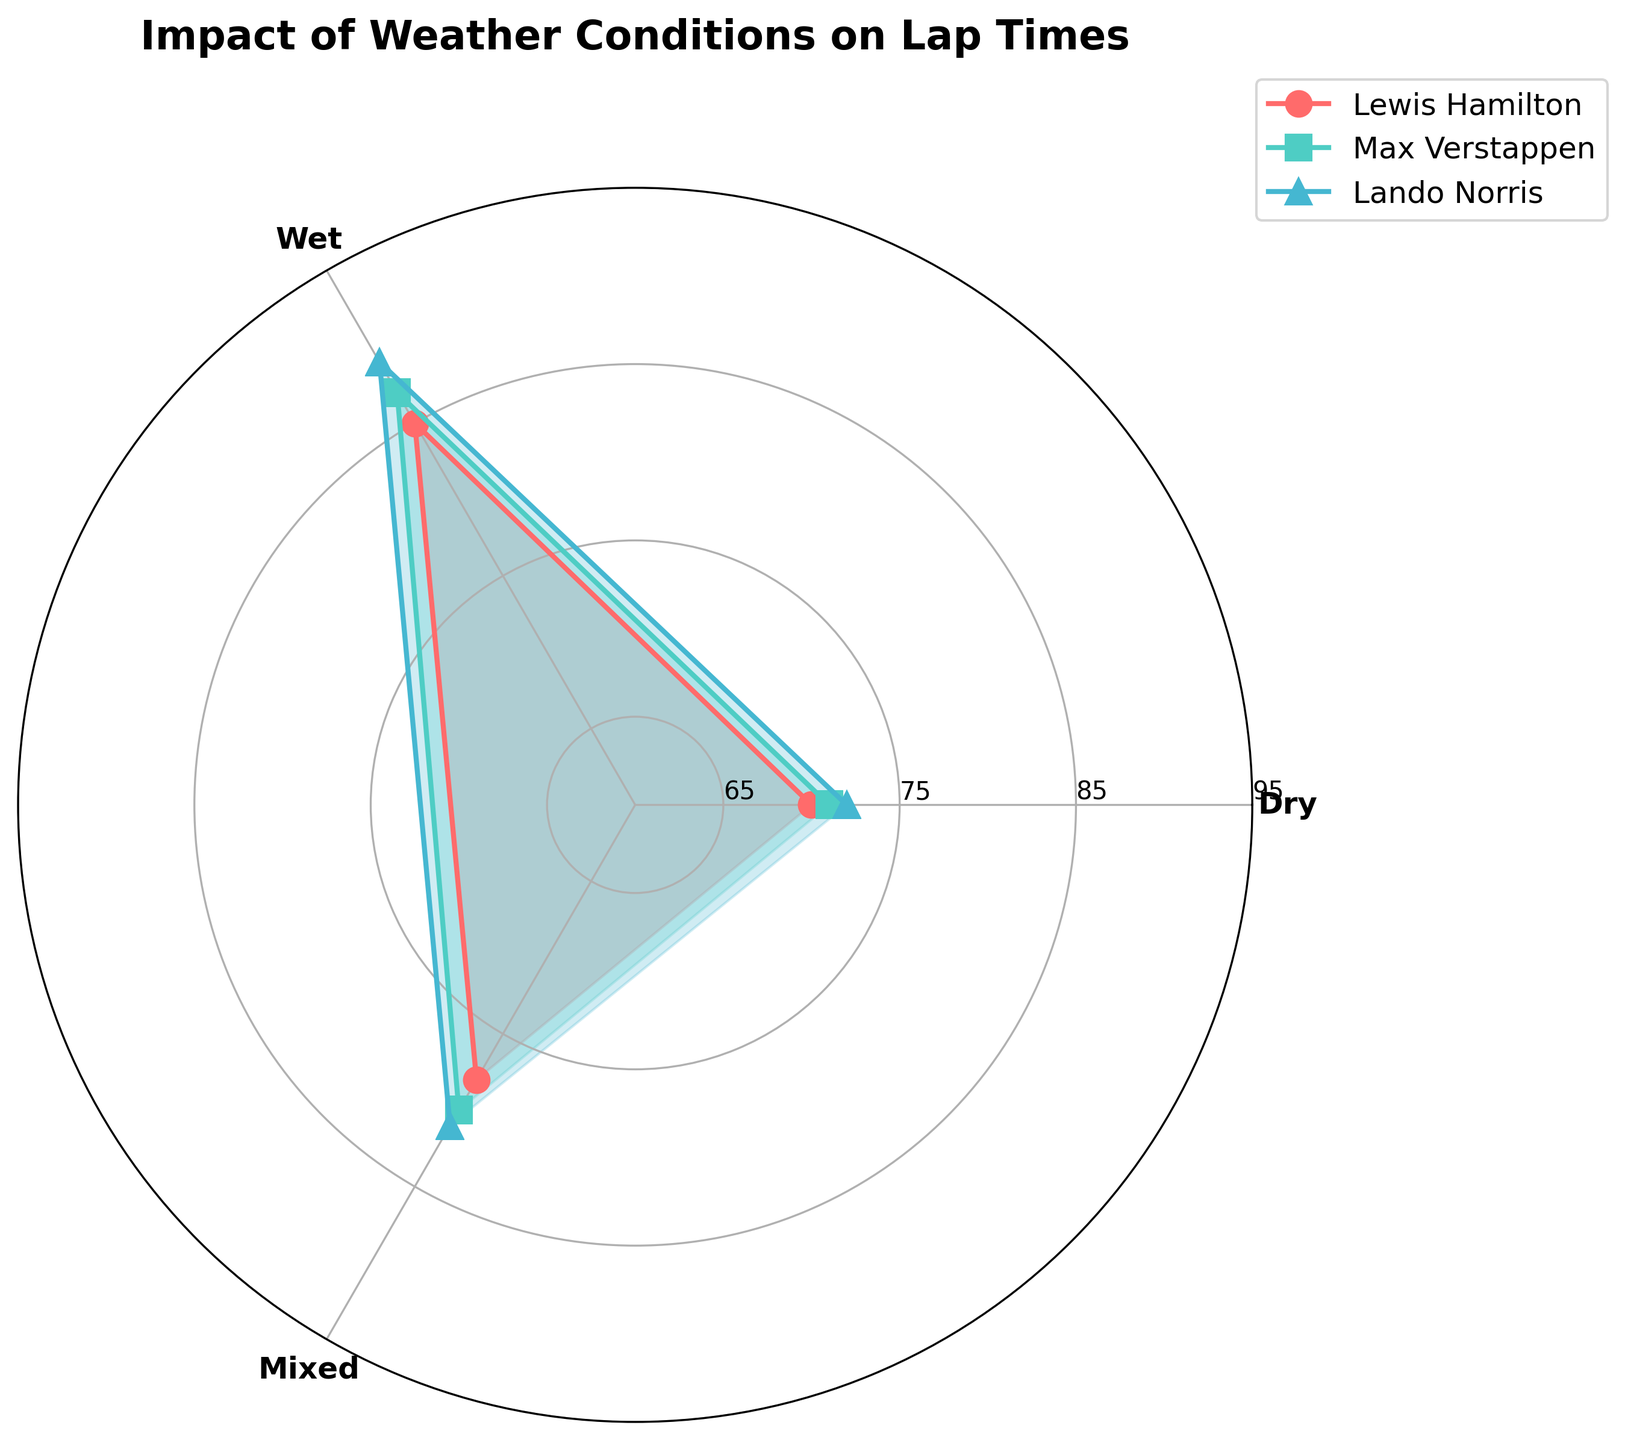What are the weather conditions shown in the figure? The figure has segments representing different weather conditions. We can see labels for each condition on the plot.
Answer: Dry, Wet, Mixed Which driver has the fastest lap time in dry conditions? By looking at the plot and identifying the shortest radius in the segment labeled "Dry," we can see which driver has the fastest lap time.
Answer: Lewis Hamilton How many weather conditions are represented in the figure? The plot divides the circle into several segments, each labeled with a different weather condition. We can count these segments.
Answer: 3 What is the title of the chart? The title is usually displayed prominently at the top of the figure. We need to read the text in this position.
Answer: Impact of Weather Conditions on Lap Times Which driver has the slowest lap time in wet conditions? We need to look at the segment labeled "Wet" and find the longest radius, which represents the slowest lap time.
Answer: Lando Norris What is the average lap time for Max Verstappen across all weather conditions? We need to sum up Max Verstappen's lap times for each weather condition (71, 87, 80) and then divide by the number of conditions (3).
Answer: 79.33 seconds Is there any driver who has the same lap time in two different weather conditions? By checking each driver's lap times across the three segments, we can see if any two radii for a single driver are equal.
Answer: No Compare the lap times of Lewis Hamilton in dry and wet conditions. Who has the larger difference? We need to subtract Lewis Hamilton's lap time in dry conditions from his lap time in wet conditions and then repeat for other drivers to find the largest difference.
Answer: Lewis Hamilton, 15 seconds Which driver shows the least variation in lap times across different weather conditions? We need to compare the differences between the maximum and minimum lap times for each driver and identify the driver with the smallest range.
Answer: Lando Norris How does the overall trend of lap times change from dry to mixed to wet conditions for all drivers? By observing the shape of the plots for each driver and summarizing the changes in radii from dry to mixed to wet conditions, we can describe the overall trend.
Answer: Lap times generally increase from dry to mixed to wet conditions 